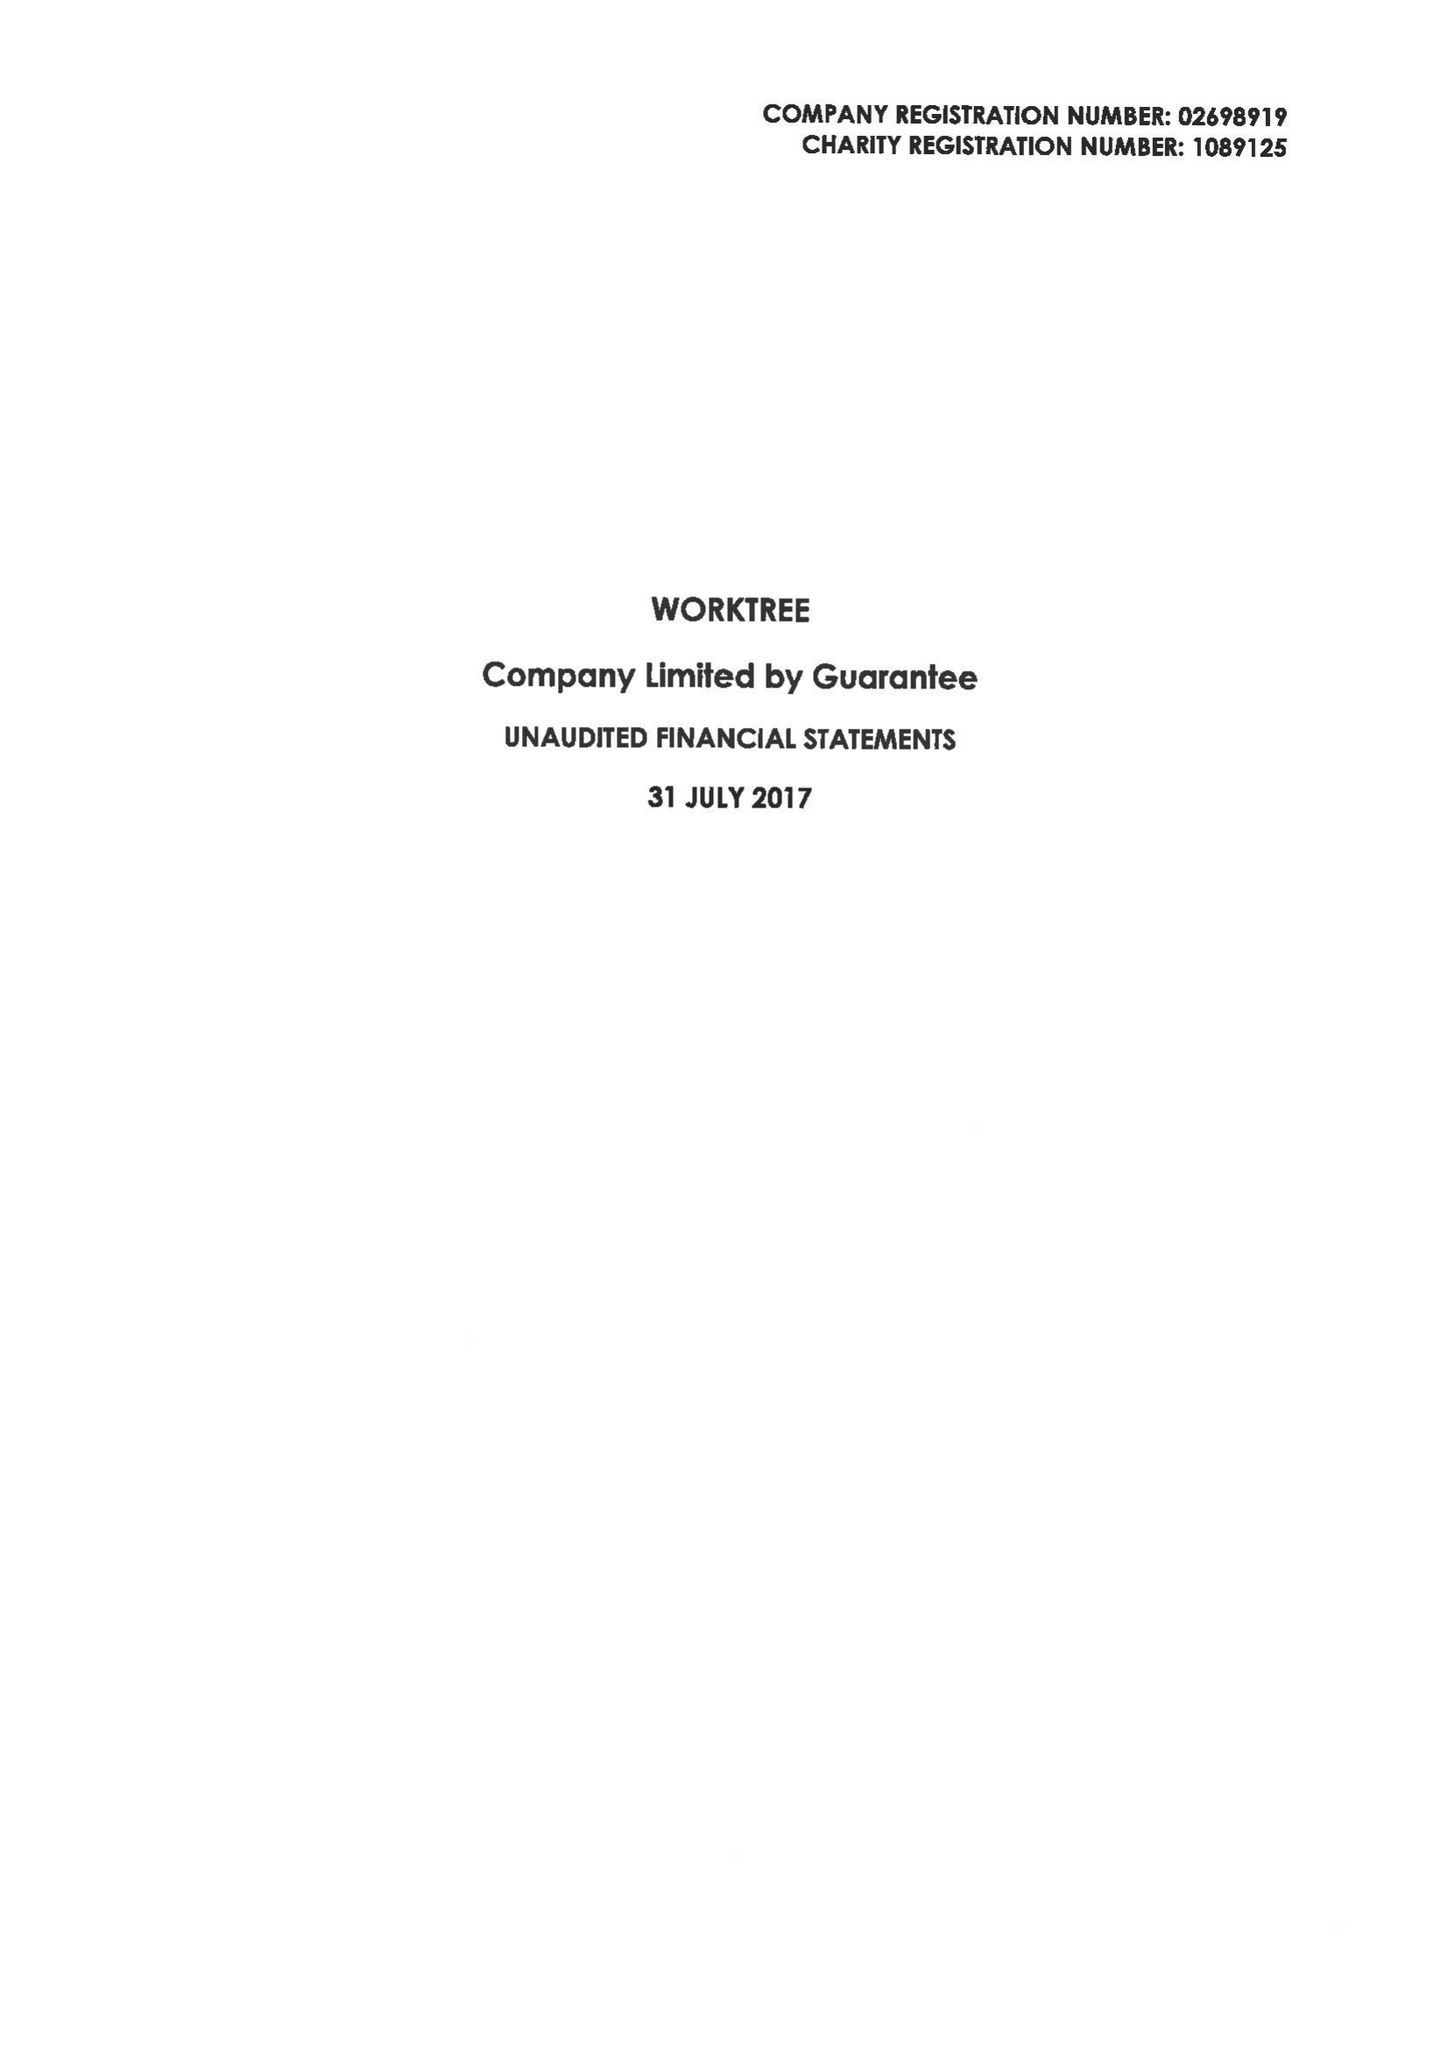What is the value for the income_annually_in_british_pounds?
Answer the question using a single word or phrase. 77282.00 